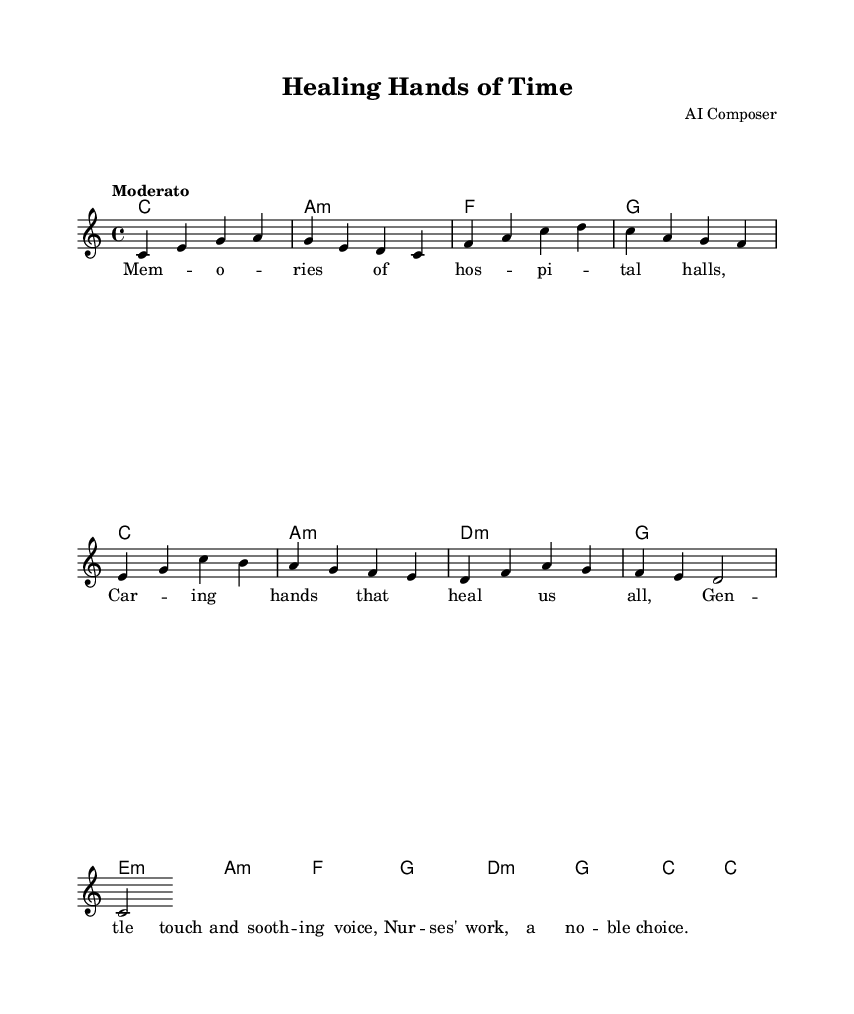What is the key signature of this music? The key signature indicated in the score is C major, which has no sharps or flats. This can be determined by the absence of any sharp or flat symbols on the staff lines at the beginning of the piece.
Answer: C major What is the time signature of this music? The time signature is 4/4, as shown at the beginning of the score. This means there are four beats in each measure, and a quarter note receives one beat.
Answer: 4/4 What is the tempo marking for this piece? The tempo marking is "Moderato," which indicates a moderate speed. This can be found at the beginning of the score right after the time signature.
Answer: Moderato What is the title of this piece? The title of the piece is "Healing Hands of Time," as indicated at the top of the score in the header section.
Answer: Healing Hands of Time What is the first lyric line of the verse? The first line of the verse is "Memories of hospital halls." This is found in the lyrics section beneath the melody and corresponds directly to the first measure of music.
Answer: Memories of hospital halls How many measures are in the melody? The melody has a total of eight measures. This can be determined by counting the vertical lines that separate each measure in the score.
Answer: Eight What is the function of the chord "a:m" in the score? The chord "a:m" (A minor) serves as both a tonic and a subdominant in relation to C major throughout the piece, providing harmonic support to the melody it accompanies. To see this, one would look at the chord progression in relation to the melody being in C major.
Answer: Subdominant 